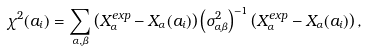Convert formula to latex. <formula><loc_0><loc_0><loc_500><loc_500>\chi ^ { 2 } ( a _ { i } ) = \sum _ { \alpha , \beta } \left ( X ^ { e x p } _ { \alpha } - X _ { \alpha } ( a _ { i } ) \right ) \left ( \sigma _ { \alpha \beta } ^ { 2 } \right ) ^ { - 1 } \left ( X ^ { e x p } _ { \alpha } - X _ { \alpha } ( a _ { i } ) \right ) ,</formula> 